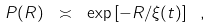<formula> <loc_0><loc_0><loc_500><loc_500>P ( R ) \ \asymp \ \exp \left [ - R / \xi ( t ) \right ] \ ,</formula> 